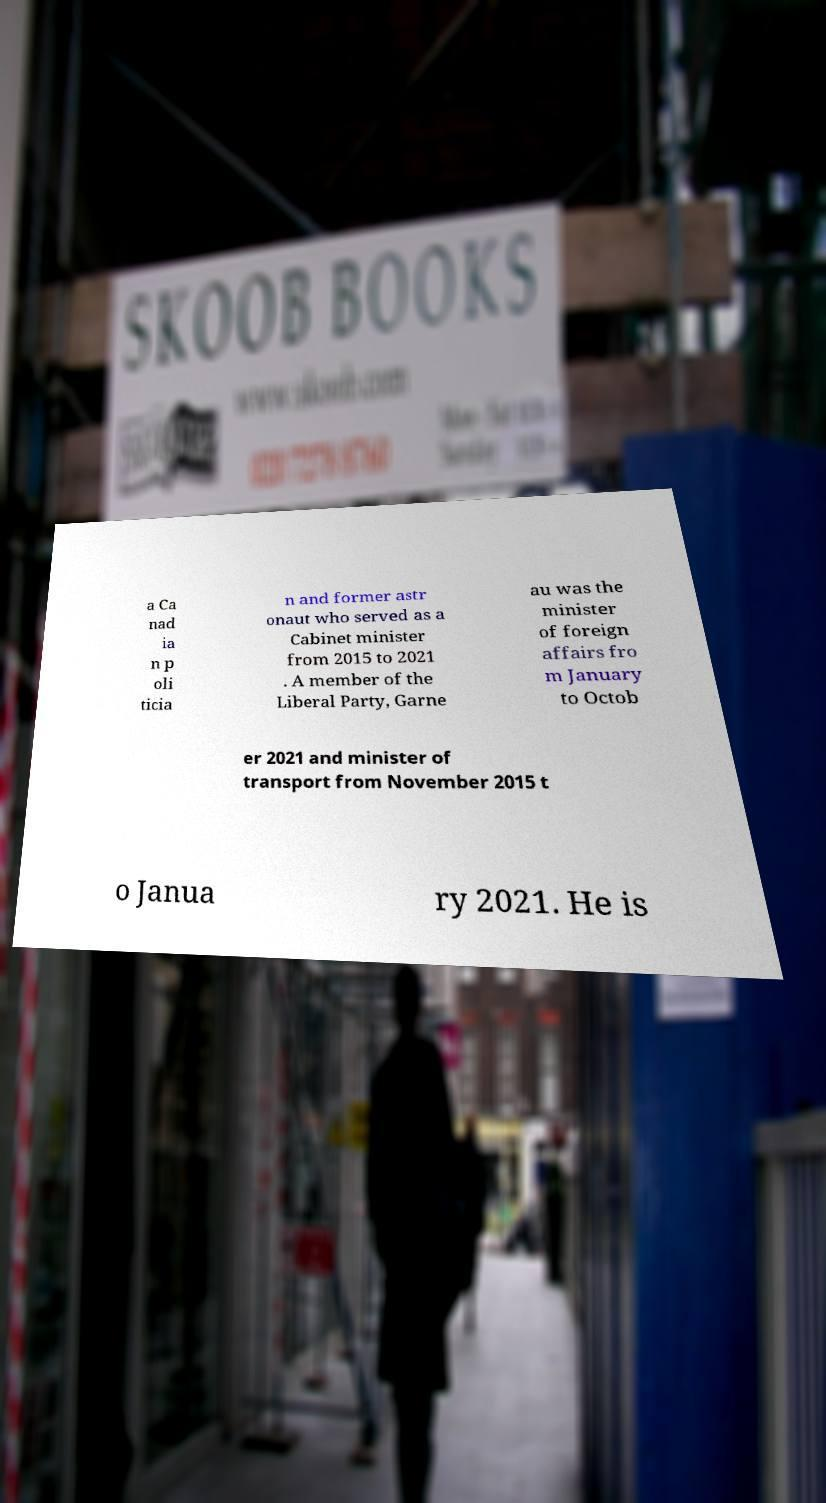I need the written content from this picture converted into text. Can you do that? a Ca nad ia n p oli ticia n and former astr onaut who served as a Cabinet minister from 2015 to 2021 . A member of the Liberal Party, Garne au was the minister of foreign affairs fro m January to Octob er 2021 and minister of transport from November 2015 t o Janua ry 2021. He is 